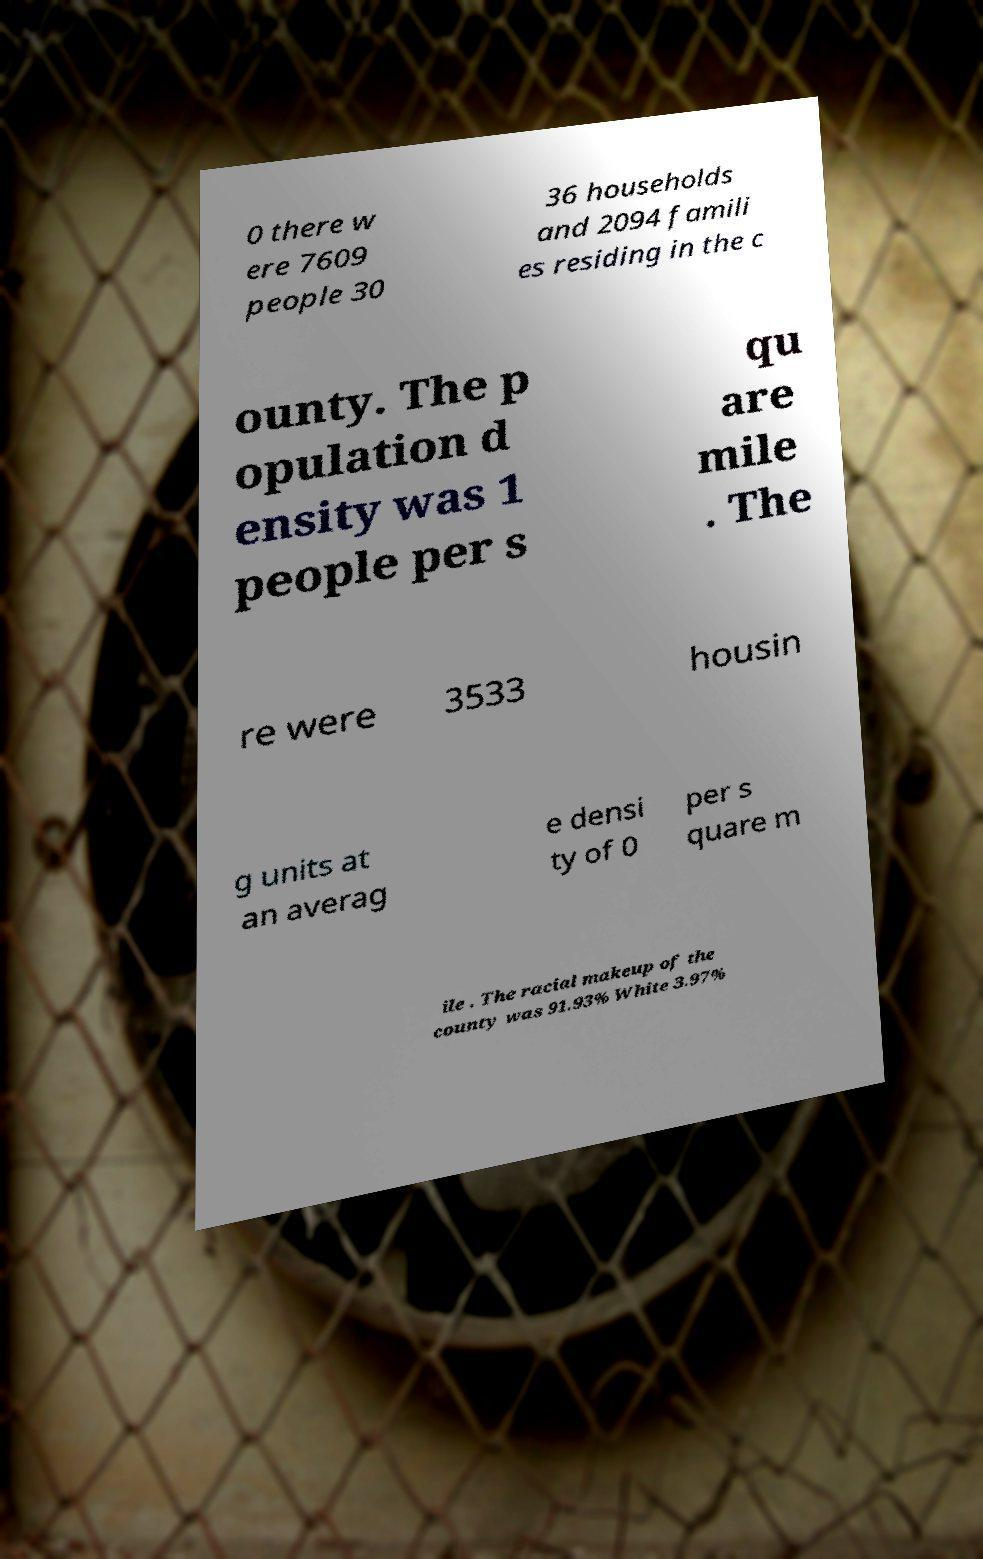Can you accurately transcribe the text from the provided image for me? 0 there w ere 7609 people 30 36 households and 2094 famili es residing in the c ounty. The p opulation d ensity was 1 people per s qu are mile . The re were 3533 housin g units at an averag e densi ty of 0 per s quare m ile . The racial makeup of the county was 91.93% White 3.97% 